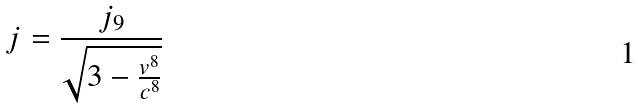Convert formula to latex. <formula><loc_0><loc_0><loc_500><loc_500>j = \frac { j _ { 9 } } { \sqrt { 3 - \frac { v ^ { 8 } } { c ^ { 8 } } } }</formula> 